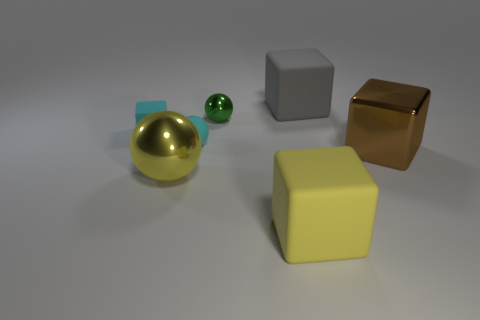What color is the sphere that is both behind the shiny block and in front of the tiny cube?
Keep it short and to the point. Cyan. There is a yellow thing on the left side of the matte sphere; is its size the same as the tiny cyan rubber sphere?
Your response must be concise. No. Is there anything else that is the same shape as the gray rubber object?
Your response must be concise. Yes. Are the green sphere and the large object to the left of the small metal ball made of the same material?
Provide a short and direct response. Yes. What number of brown things are either large metallic balls or rubber objects?
Your response must be concise. 0. Are any large balls visible?
Provide a succinct answer. Yes. Is there a large rubber block that is behind the gray matte block that is behind the large block to the right of the gray block?
Offer a very short reply. No. Are there any other things that have the same size as the metallic cube?
Ensure brevity in your answer.  Yes. Does the small green metal thing have the same shape as the cyan matte object that is in front of the small cyan block?
Your response must be concise. Yes. There is a block that is right of the large matte object to the right of the large matte thing that is on the left side of the gray thing; what color is it?
Ensure brevity in your answer.  Brown. 